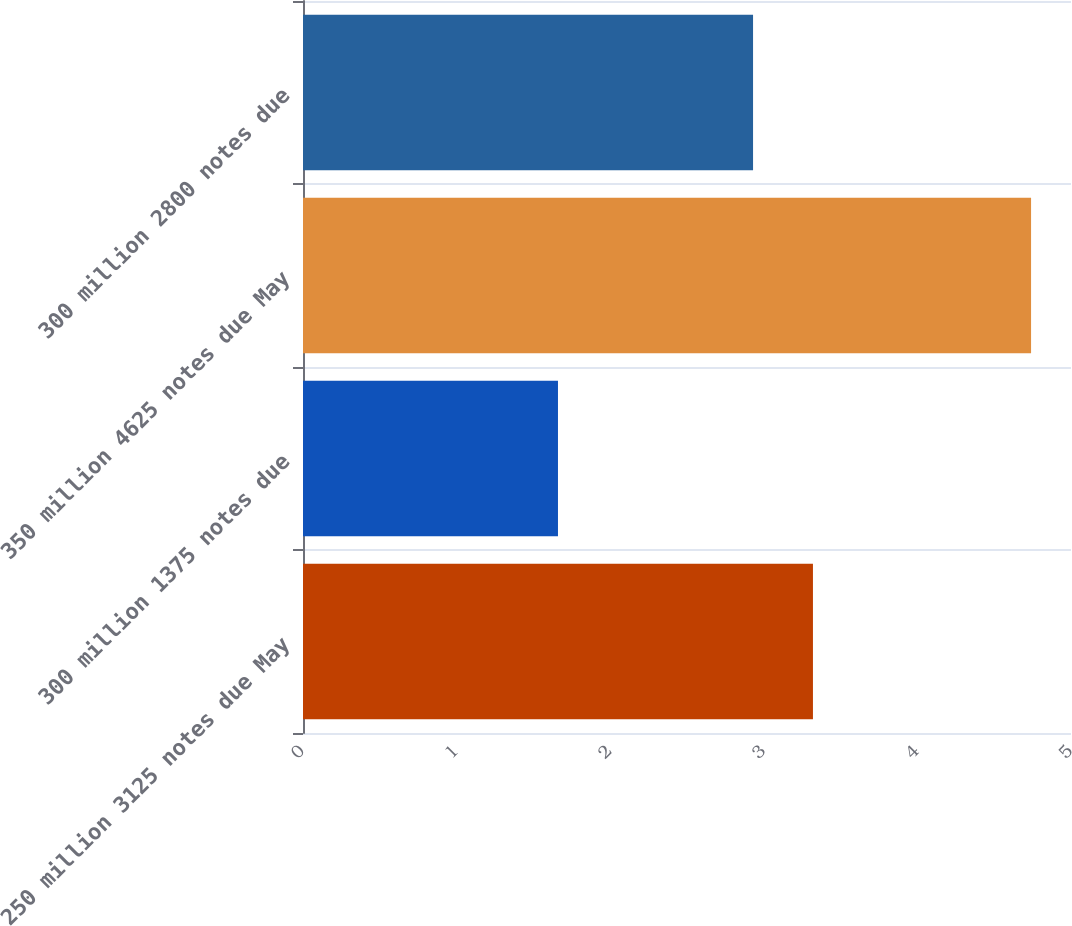<chart> <loc_0><loc_0><loc_500><loc_500><bar_chart><fcel>250 million 3125 notes due May<fcel>300 million 1375 notes due<fcel>350 million 4625 notes due May<fcel>300 million 2800 notes due<nl><fcel>3.32<fcel>1.66<fcel>4.74<fcel>2.93<nl></chart> 